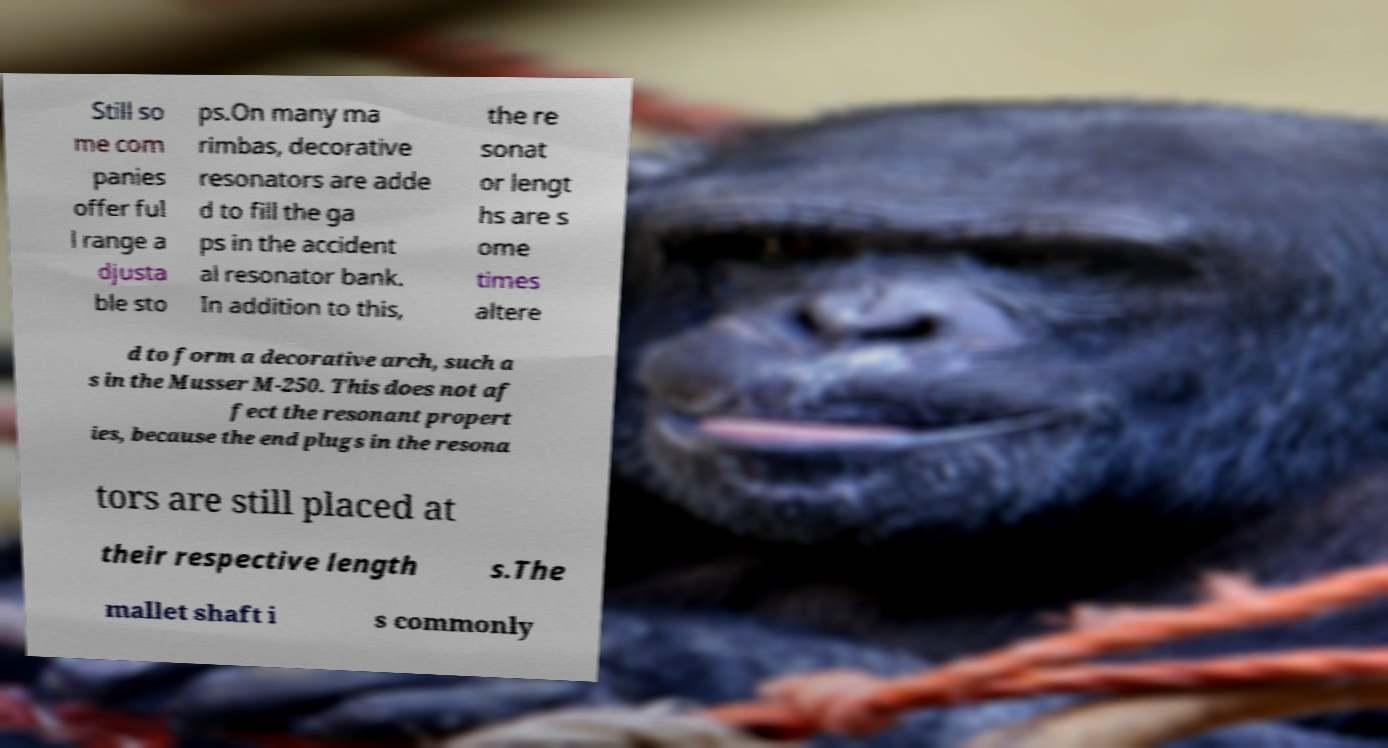Can you accurately transcribe the text from the provided image for me? Still so me com panies offer ful l range a djusta ble sto ps.On many ma rimbas, decorative resonators are adde d to fill the ga ps in the accident al resonator bank. In addition to this, the re sonat or lengt hs are s ome times altere d to form a decorative arch, such a s in the Musser M-250. This does not af fect the resonant propert ies, because the end plugs in the resona tors are still placed at their respective length s.The mallet shaft i s commonly 